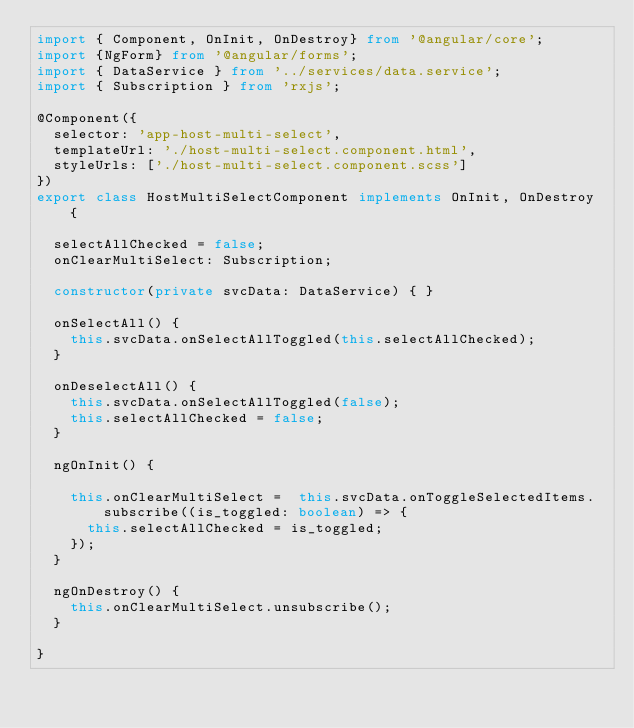Convert code to text. <code><loc_0><loc_0><loc_500><loc_500><_TypeScript_>import { Component, OnInit, OnDestroy} from '@angular/core';
import {NgForm} from '@angular/forms';
import { DataService } from '../services/data.service';
import { Subscription } from 'rxjs';

@Component({
  selector: 'app-host-multi-select',
  templateUrl: './host-multi-select.component.html',
  styleUrls: ['./host-multi-select.component.scss']
})
export class HostMultiSelectComponent implements OnInit, OnDestroy {

  selectAllChecked = false;
  onClearMultiSelect: Subscription;

  constructor(private svcData: DataService) { }

  onSelectAll() {
    this.svcData.onSelectAllToggled(this.selectAllChecked);
  }

  onDeselectAll() {
    this.svcData.onSelectAllToggled(false);
    this.selectAllChecked = false;
  }

  ngOnInit() {

    this.onClearMultiSelect =  this.svcData.onToggleSelectedItems.subscribe((is_toggled: boolean) => {
      this.selectAllChecked = is_toggled;
    });
  }

  ngOnDestroy() {
    this.onClearMultiSelect.unsubscribe();
  }

}

</code> 